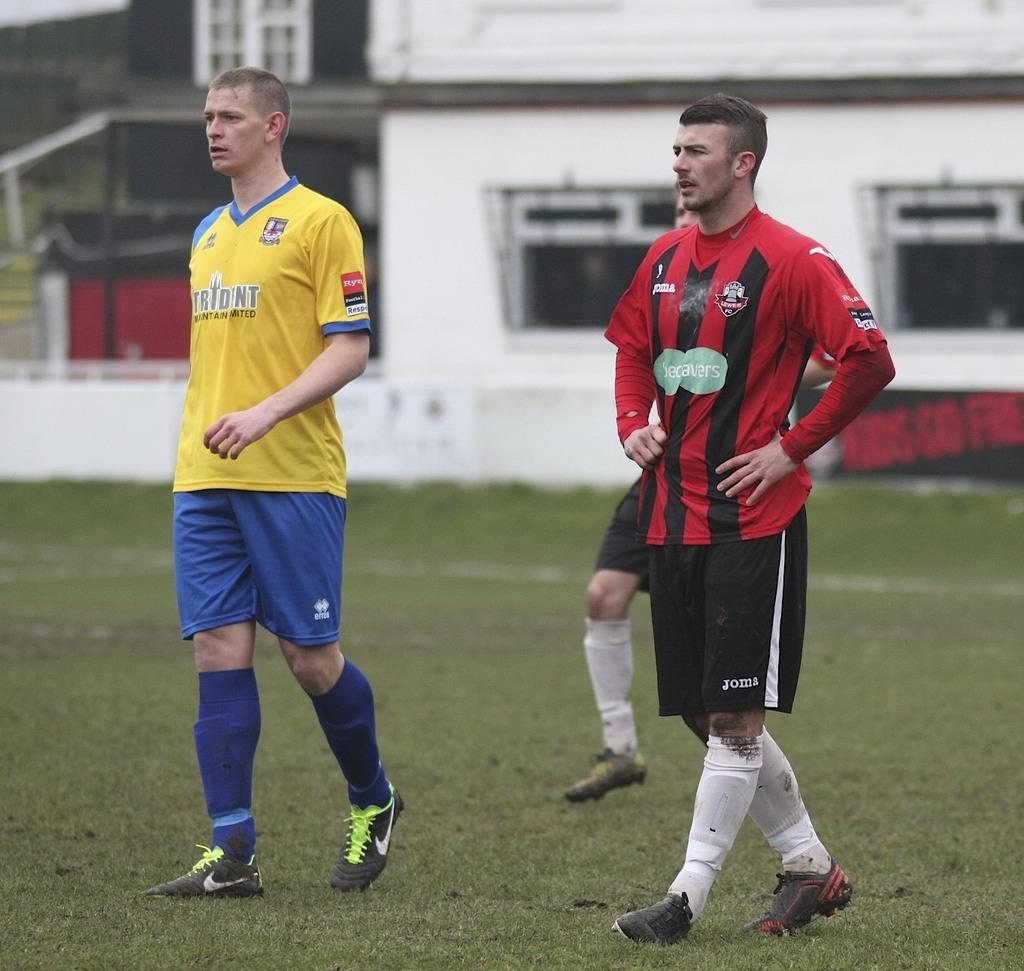Provide a one-sentence caption for the provided image. Two soccer players one in yellow jersey that says Tridentand another in red that says becavers. 